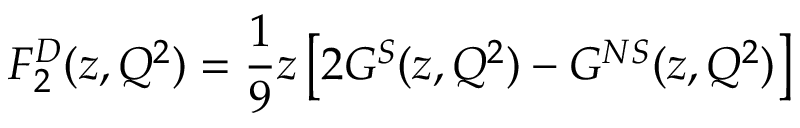<formula> <loc_0><loc_0><loc_500><loc_500>F _ { 2 } ^ { D } ( z , Q ^ { 2 } ) = \frac { 1 } { 9 } z \left [ 2 G ^ { S } ( z , Q ^ { 2 } ) - G ^ { N S } ( z , Q ^ { 2 } ) \right ]</formula> 